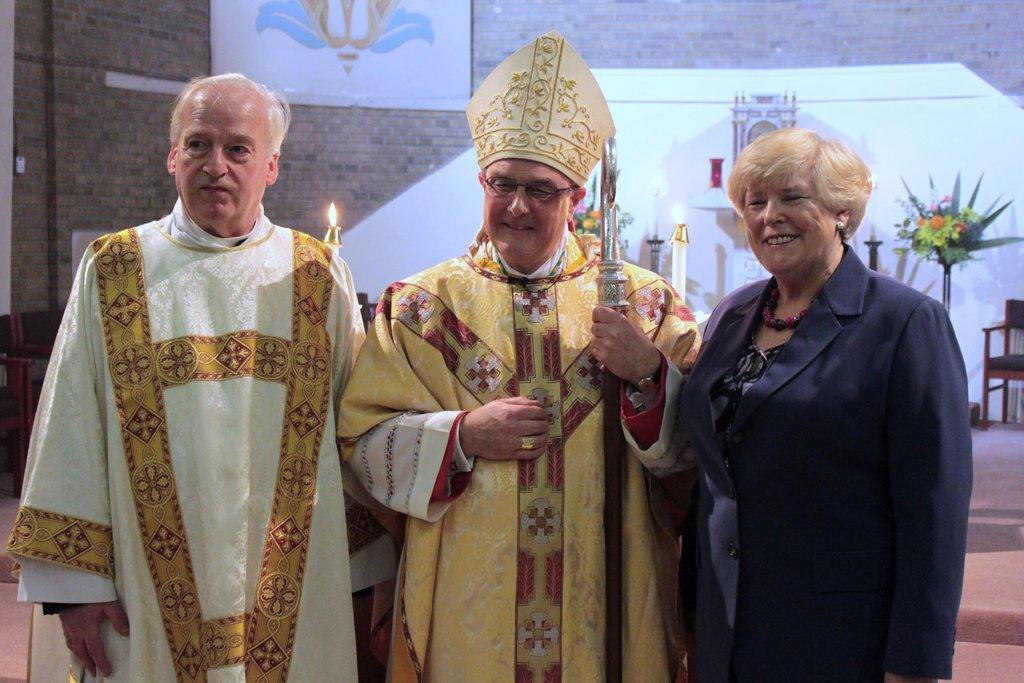Can you describe this image briefly? In this image, we can see three people in the middle. In the background, we can see some candles, chair, plant with some flowers and a frame which is attached to a brick wall. 